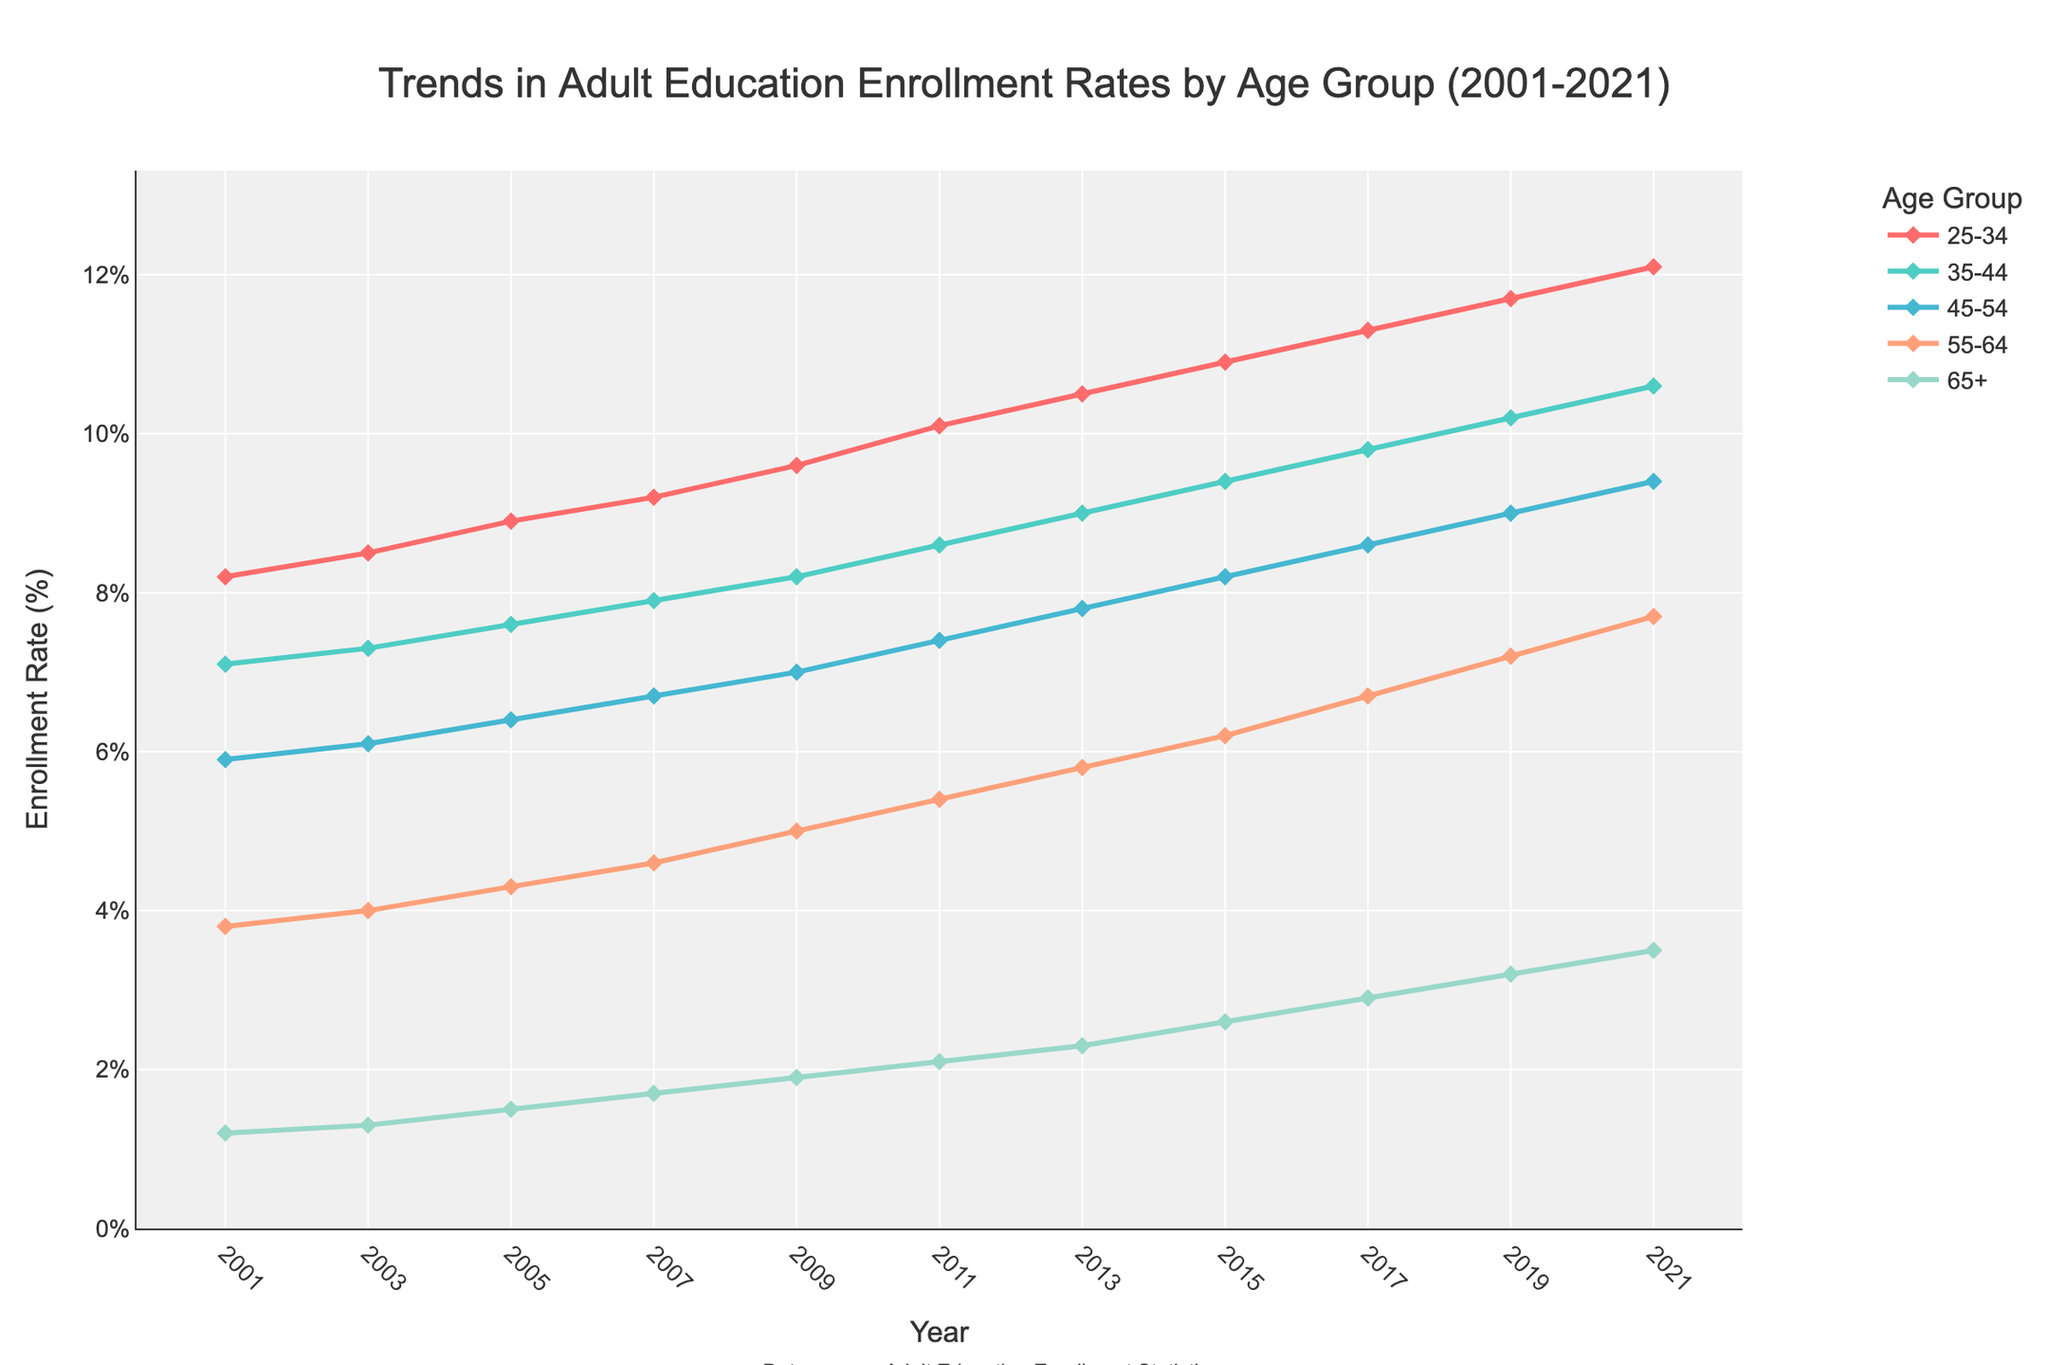What is the enrollment rate trend for the 25-34 age group over the past 20 years? The trend for the 25-34 age group shows a steady increase in enrollment rates from 8.2% in 2001 to 12.1% in 2021. The rate has consistently risen every two years over this period.
Answer: Steady increase from 8.2% to 12.1% Which age group had the highest enrollment rate in 2021? Looking at the data points for 2021, the 25-34 age group has the highest enrollment rate at 12.1%.
Answer: 25-34 How has the enrollment rate for the 65+ age group changed from 2001 to 2021? The enrollment rate for the 65+ age group increased from 1.2% in 2001 to 3.5% in 2021. There is a noticeable upward trend over the years.
Answer: Increased from 1.2% to 3.5% Compare the enrollment rate trends for the 35-44 and 55-64 age groups. Which group had a larger increase? The 35-44 age group increased from 7.1% to 10.6%, a total increase of 3.5%. The 55-64 age group increased from 3.8% to 7.7%, a total increase of 3.9%. Hence, the 55-64 age group had a slightly larger increase.
Answer: 55-64 had a larger increase What is the gap in enrollment rates between the 25-34 and 65+ age groups in 2021? In 2021, the enrollment rate for the 25-34 age group is 12.1% and for the 65+ age group is 3.5%. The difference is 12.1% - 3.5% = 8.6%.
Answer: 8.6% Which age group showed the most consistent increase in enrollment rate over the given years? All age groups show an upward trend, but the 25-34 age group shows the most consistent increase with no drop across the time span, rising steadily from 8.2% to 12.1%.
Answer: 25-34 What is the average enrollment rate of the 45-54 age group between 2001 and 2021? Sum the rates for the 45-54 age group: (5.9 + 6.1 + 6.4 + 6.7 + 7.0 + 7.4 + 7.8 + 8.2 + 8.6 + 9.0 + 9.4) = 82.5. There are 11 data points, so average = 82.5 / 11 = 7.5%.
Answer: 7.5% Which age group has the smallest enrollment rate increase compared to other groups between 2001 and 2021? Compare the increases for each group: 25-34: 3.9%, 35-44: 3.5%, 45-54: 3.5%, 55-64: 3.9%, 65+: 2.3%. The 65+ age group has the smallest increase.
Answer: 65+ What is the typical pattern observed in the enrollment rates for older age groups (55-64, 65+) over the years? Both older age groups (55-64, 65+) show increasing trends. For the 55-64 age group, the rate increases more steadily, while the 65+ age group, although increasing, has smaller increments.
Answer: Increasing trend with smaller increments for 65+ 